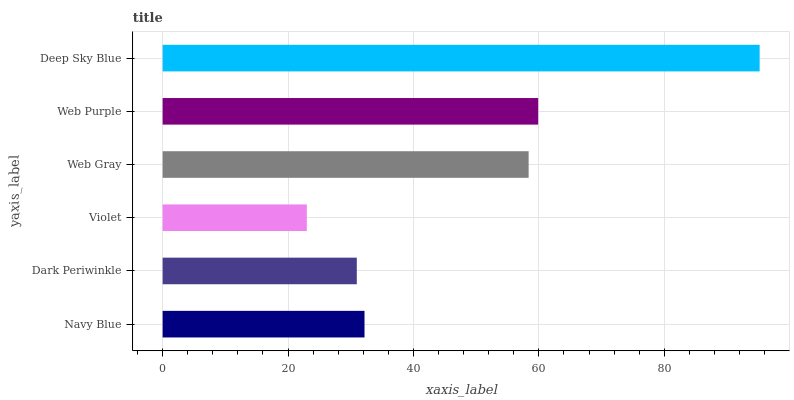Is Violet the minimum?
Answer yes or no. Yes. Is Deep Sky Blue the maximum?
Answer yes or no. Yes. Is Dark Periwinkle the minimum?
Answer yes or no. No. Is Dark Periwinkle the maximum?
Answer yes or no. No. Is Navy Blue greater than Dark Periwinkle?
Answer yes or no. Yes. Is Dark Periwinkle less than Navy Blue?
Answer yes or no. Yes. Is Dark Periwinkle greater than Navy Blue?
Answer yes or no. No. Is Navy Blue less than Dark Periwinkle?
Answer yes or no. No. Is Web Gray the high median?
Answer yes or no. Yes. Is Navy Blue the low median?
Answer yes or no. Yes. Is Navy Blue the high median?
Answer yes or no. No. Is Web Gray the low median?
Answer yes or no. No. 